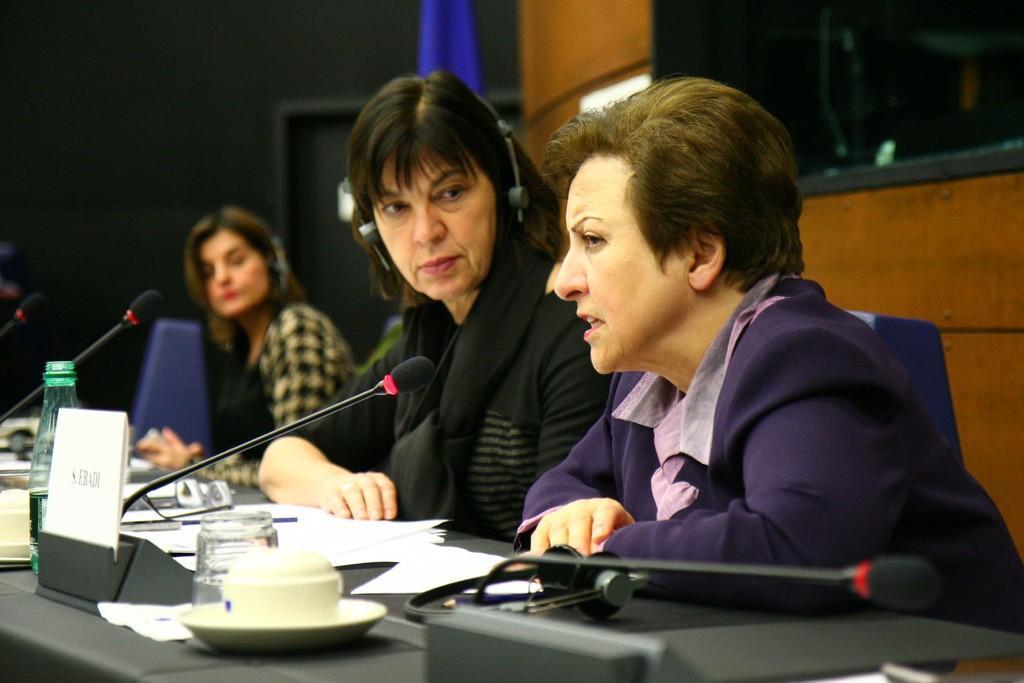In one or two sentences, can you explain what this image depicts? In this picture we can see group of people, they are all seated, in front of them we can see few microphones, papers, bottle, spectacles, glass, headphones and other things on the table. 